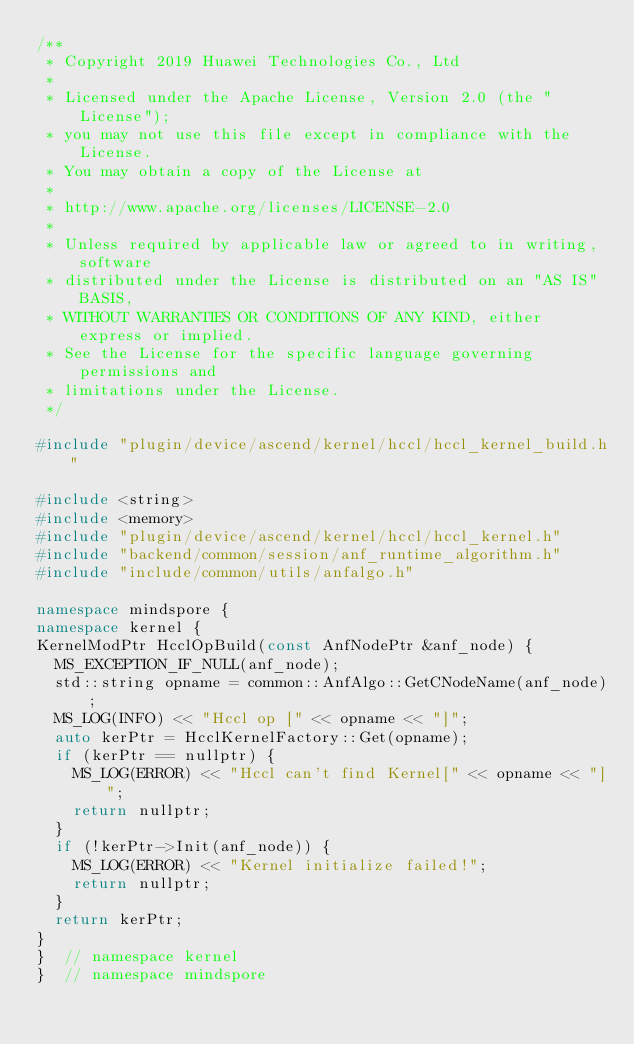Convert code to text. <code><loc_0><loc_0><loc_500><loc_500><_C++_>/**
 * Copyright 2019 Huawei Technologies Co., Ltd
 *
 * Licensed under the Apache License, Version 2.0 (the "License");
 * you may not use this file except in compliance with the License.
 * You may obtain a copy of the License at
 *
 * http://www.apache.org/licenses/LICENSE-2.0
 *
 * Unless required by applicable law or agreed to in writing, software
 * distributed under the License is distributed on an "AS IS" BASIS,
 * WITHOUT WARRANTIES OR CONDITIONS OF ANY KIND, either express or implied.
 * See the License for the specific language governing permissions and
 * limitations under the License.
 */

#include "plugin/device/ascend/kernel/hccl/hccl_kernel_build.h"

#include <string>
#include <memory>
#include "plugin/device/ascend/kernel/hccl/hccl_kernel.h"
#include "backend/common/session/anf_runtime_algorithm.h"
#include "include/common/utils/anfalgo.h"

namespace mindspore {
namespace kernel {
KernelModPtr HcclOpBuild(const AnfNodePtr &anf_node) {
  MS_EXCEPTION_IF_NULL(anf_node);
  std::string opname = common::AnfAlgo::GetCNodeName(anf_node);
  MS_LOG(INFO) << "Hccl op [" << opname << "]";
  auto kerPtr = HcclKernelFactory::Get(opname);
  if (kerPtr == nullptr) {
    MS_LOG(ERROR) << "Hccl can't find Kernel[" << opname << "]";
    return nullptr;
  }
  if (!kerPtr->Init(anf_node)) {
    MS_LOG(ERROR) << "Kernel initialize failed!";
    return nullptr;
  }
  return kerPtr;
}
}  // namespace kernel
}  // namespace mindspore
</code> 